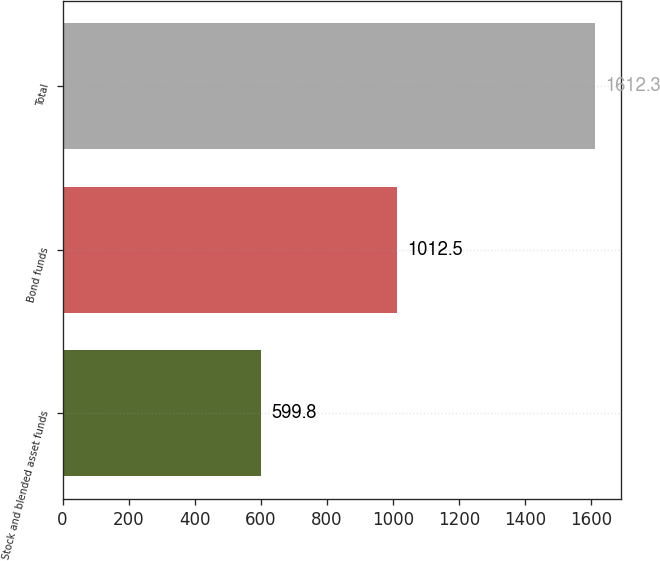Convert chart. <chart><loc_0><loc_0><loc_500><loc_500><bar_chart><fcel>Stock and blended asset funds<fcel>Bond funds<fcel>Total<nl><fcel>599.8<fcel>1012.5<fcel>1612.3<nl></chart> 